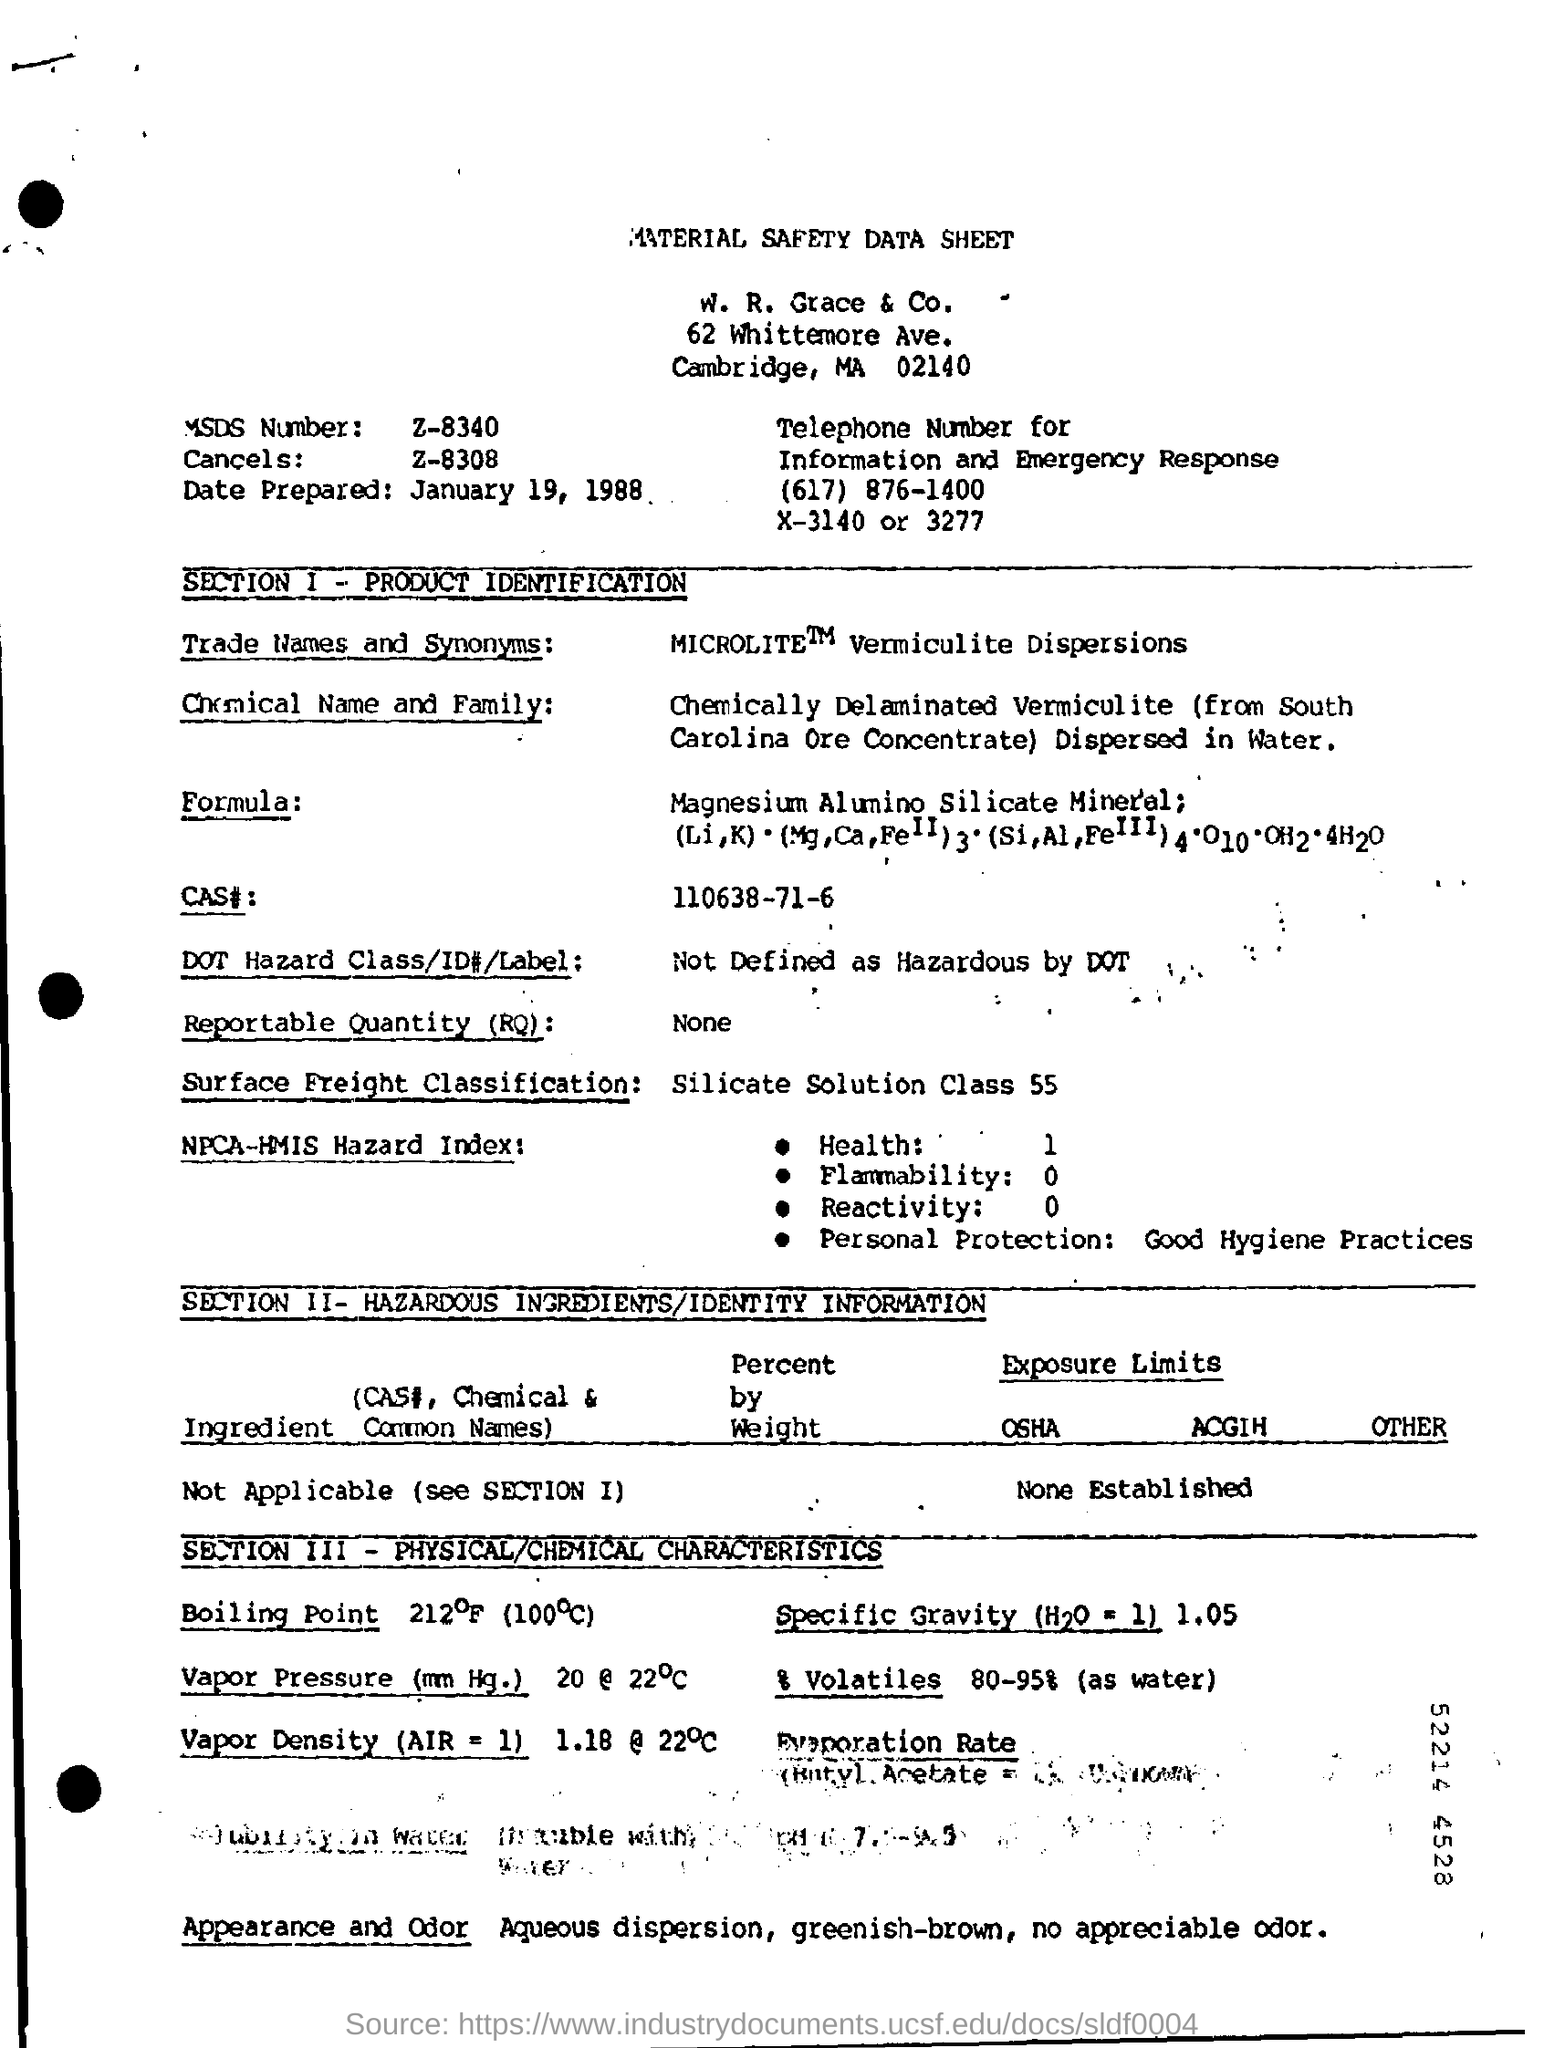Point out several critical features in this image. The heading at the top of the page is "Material Safety Data Sheet. 